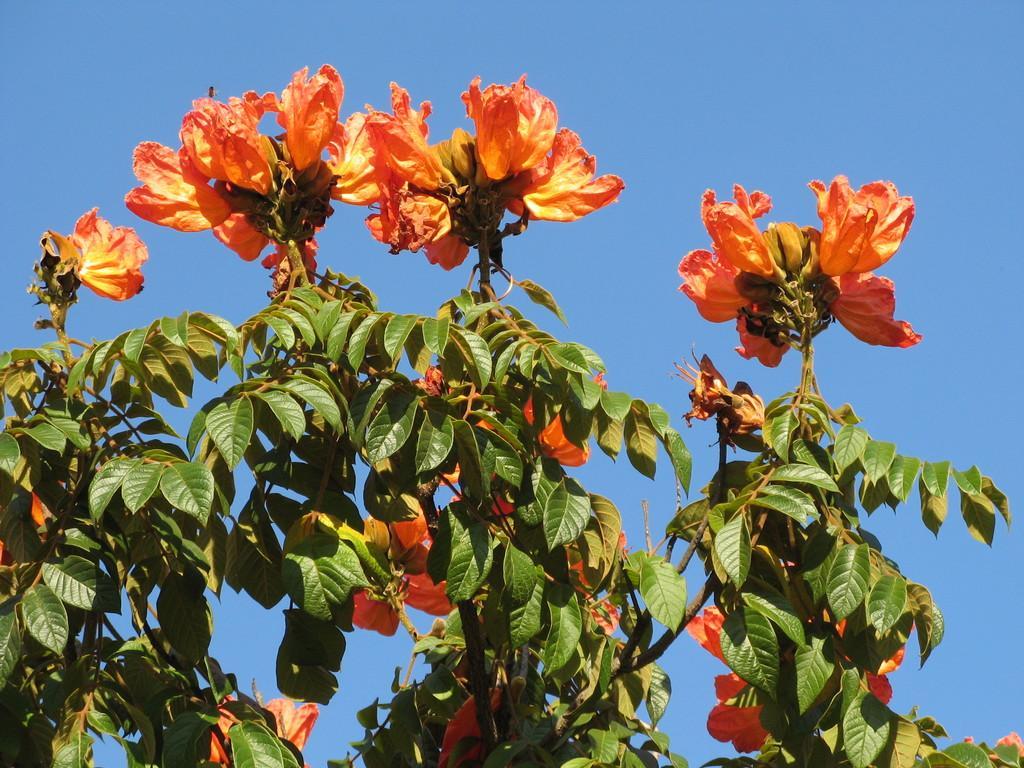Please provide a concise description of this image. In the middle of the image we can see some trees and flowers. Behind the trees we can see the sky. 